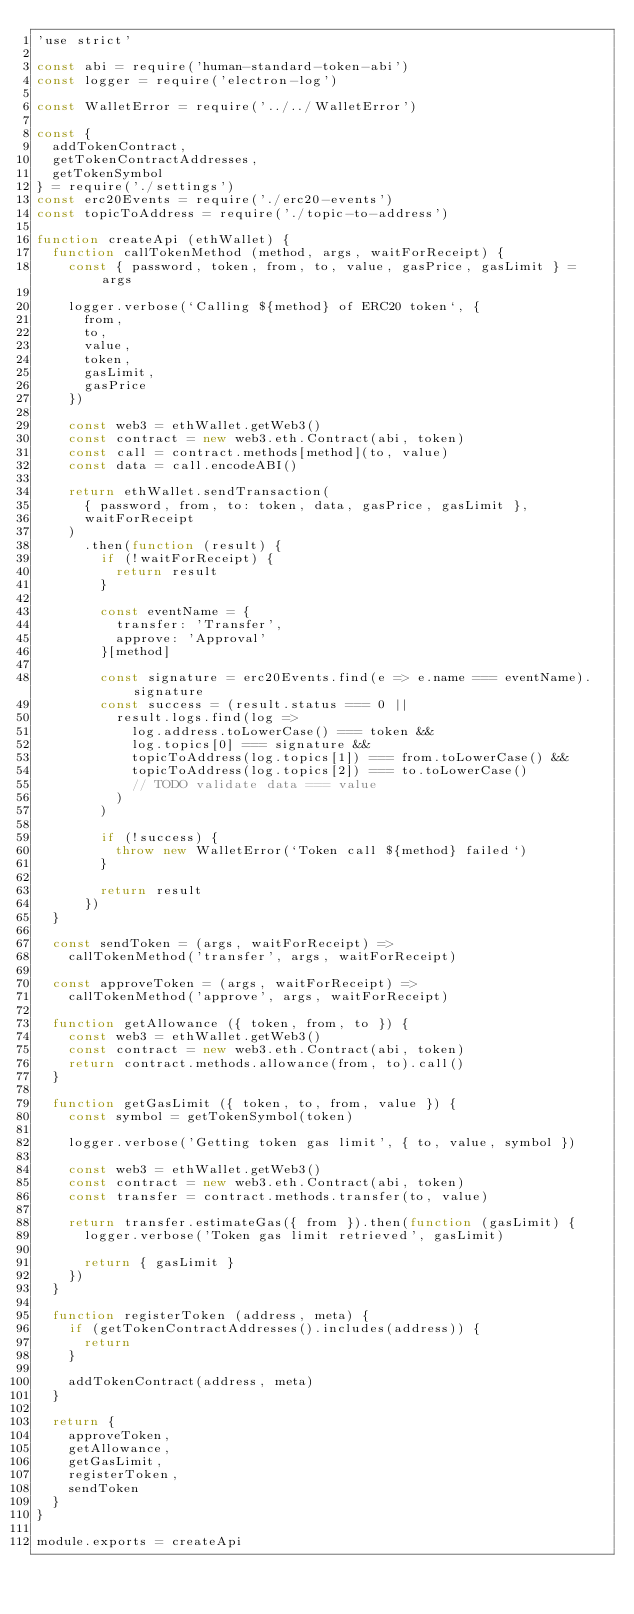Convert code to text. <code><loc_0><loc_0><loc_500><loc_500><_JavaScript_>'use strict'

const abi = require('human-standard-token-abi')
const logger = require('electron-log')

const WalletError = require('../../WalletError')

const {
  addTokenContract,
  getTokenContractAddresses,
  getTokenSymbol
} = require('./settings')
const erc20Events = require('./erc20-events')
const topicToAddress = require('./topic-to-address')

function createApi (ethWallet) {
  function callTokenMethod (method, args, waitForReceipt) {
    const { password, token, from, to, value, gasPrice, gasLimit } = args

    logger.verbose(`Calling ${method} of ERC20 token`, {
      from,
      to,
      value,
      token,
      gasLimit,
      gasPrice
    })

    const web3 = ethWallet.getWeb3()
    const contract = new web3.eth.Contract(abi, token)
    const call = contract.methods[method](to, value)
    const data = call.encodeABI()

    return ethWallet.sendTransaction(
      { password, from, to: token, data, gasPrice, gasLimit },
      waitForReceipt
    )
      .then(function (result) {
        if (!waitForReceipt) {
          return result
        }

        const eventName = {
          transfer: 'Transfer',
          approve: 'Approval'
        }[method]

        const signature = erc20Events.find(e => e.name === eventName).signature
        const success = (result.status === 0 ||
          result.logs.find(log =>
            log.address.toLowerCase() === token &&
            log.topics[0] === signature &&
            topicToAddress(log.topics[1]) === from.toLowerCase() &&
            topicToAddress(log.topics[2]) === to.toLowerCase()
            // TODO validate data === value
          )
        )

        if (!success) {
          throw new WalletError(`Token call ${method} failed`)
        }

        return result
      })
  }

  const sendToken = (args, waitForReceipt) =>
    callTokenMethod('transfer', args, waitForReceipt)

  const approveToken = (args, waitForReceipt) =>
    callTokenMethod('approve', args, waitForReceipt)

  function getAllowance ({ token, from, to }) {
    const web3 = ethWallet.getWeb3()
    const contract = new web3.eth.Contract(abi, token)
    return contract.methods.allowance(from, to).call()
  }

  function getGasLimit ({ token, to, from, value }) {
    const symbol = getTokenSymbol(token)

    logger.verbose('Getting token gas limit', { to, value, symbol })

    const web3 = ethWallet.getWeb3()
    const contract = new web3.eth.Contract(abi, token)
    const transfer = contract.methods.transfer(to, value)

    return transfer.estimateGas({ from }).then(function (gasLimit) {
      logger.verbose('Token gas limit retrieved', gasLimit)

      return { gasLimit }
    })
  }

  function registerToken (address, meta) {
    if (getTokenContractAddresses().includes(address)) {
      return
    }

    addTokenContract(address, meta)
  }

  return {
    approveToken,
    getAllowance,
    getGasLimit,
    registerToken,
    sendToken
  }
}

module.exports = createApi
</code> 